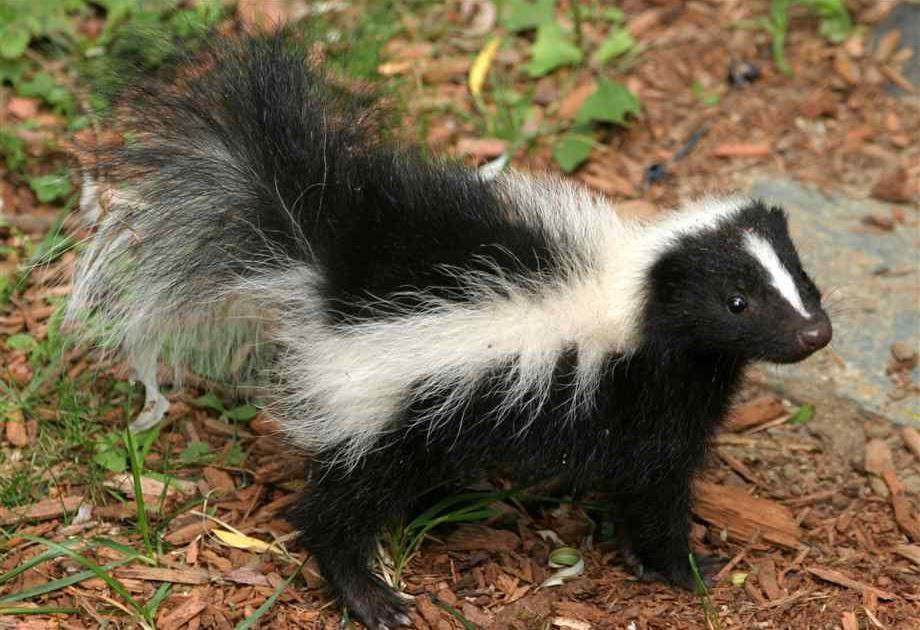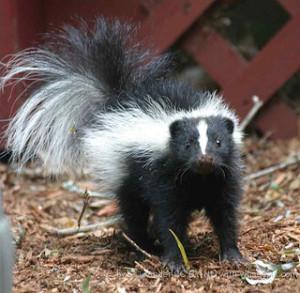The first image is the image on the left, the second image is the image on the right. Considering the images on both sides, is "The skunk in the right image is facing right." valid? Answer yes or no. No. The first image is the image on the left, the second image is the image on the right. For the images displayed, is the sentence "One skunk is on all fours facing directly forward, and the other skunk is standing on all fours with its body turned rightward and gaze angled forward." factually correct? Answer yes or no. Yes. 